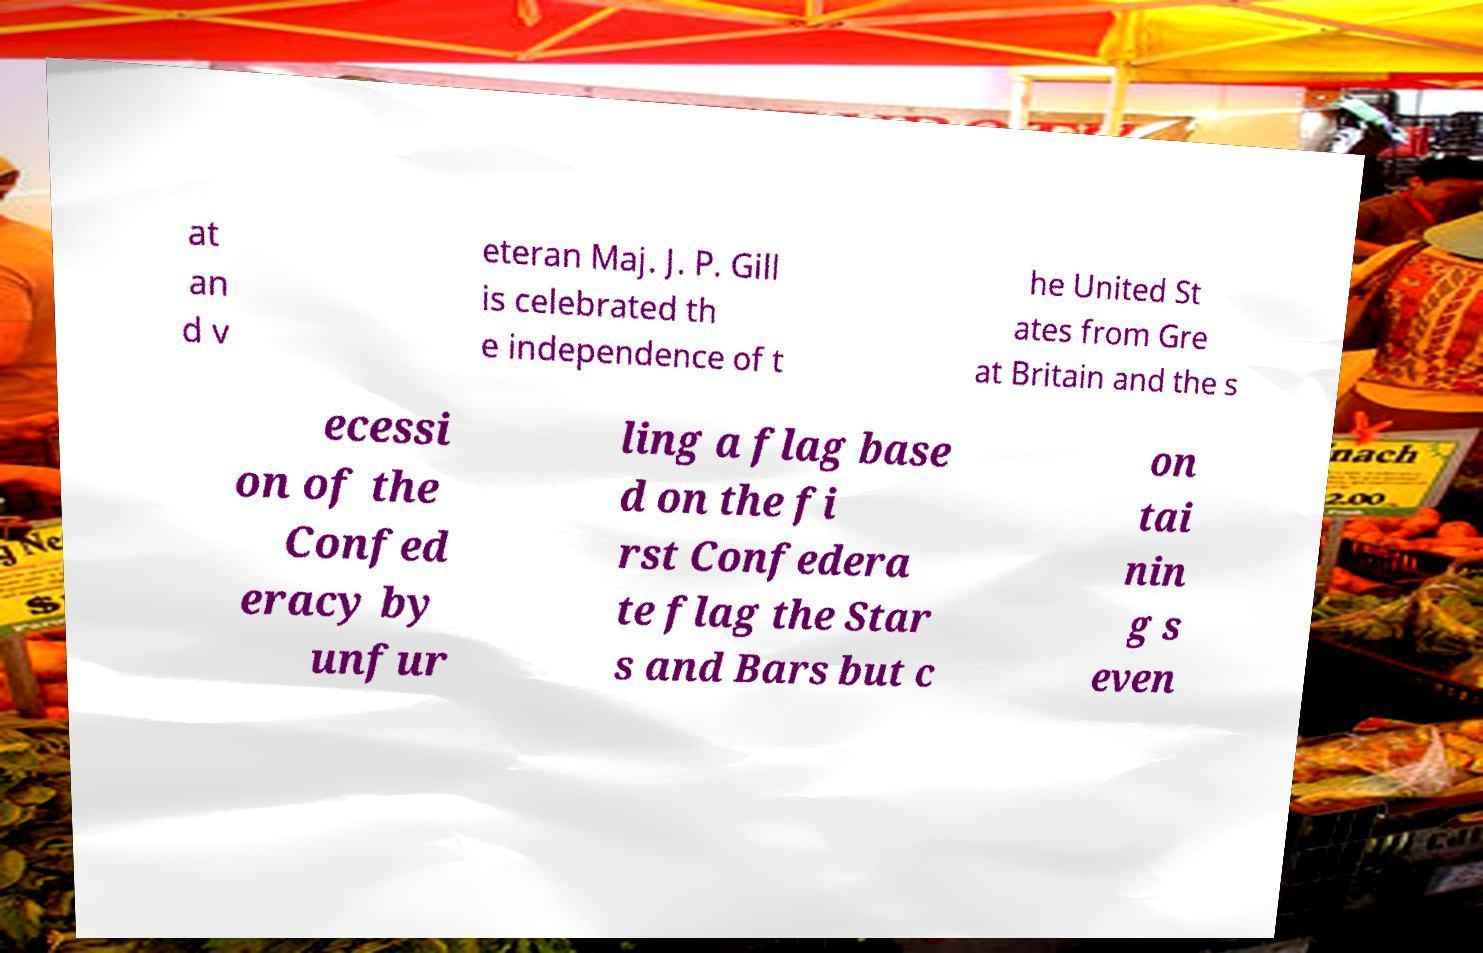Can you read and provide the text displayed in the image?This photo seems to have some interesting text. Can you extract and type it out for me? at an d v eteran Maj. J. P. Gill is celebrated th e independence of t he United St ates from Gre at Britain and the s ecessi on of the Confed eracy by unfur ling a flag base d on the fi rst Confedera te flag the Star s and Bars but c on tai nin g s even 